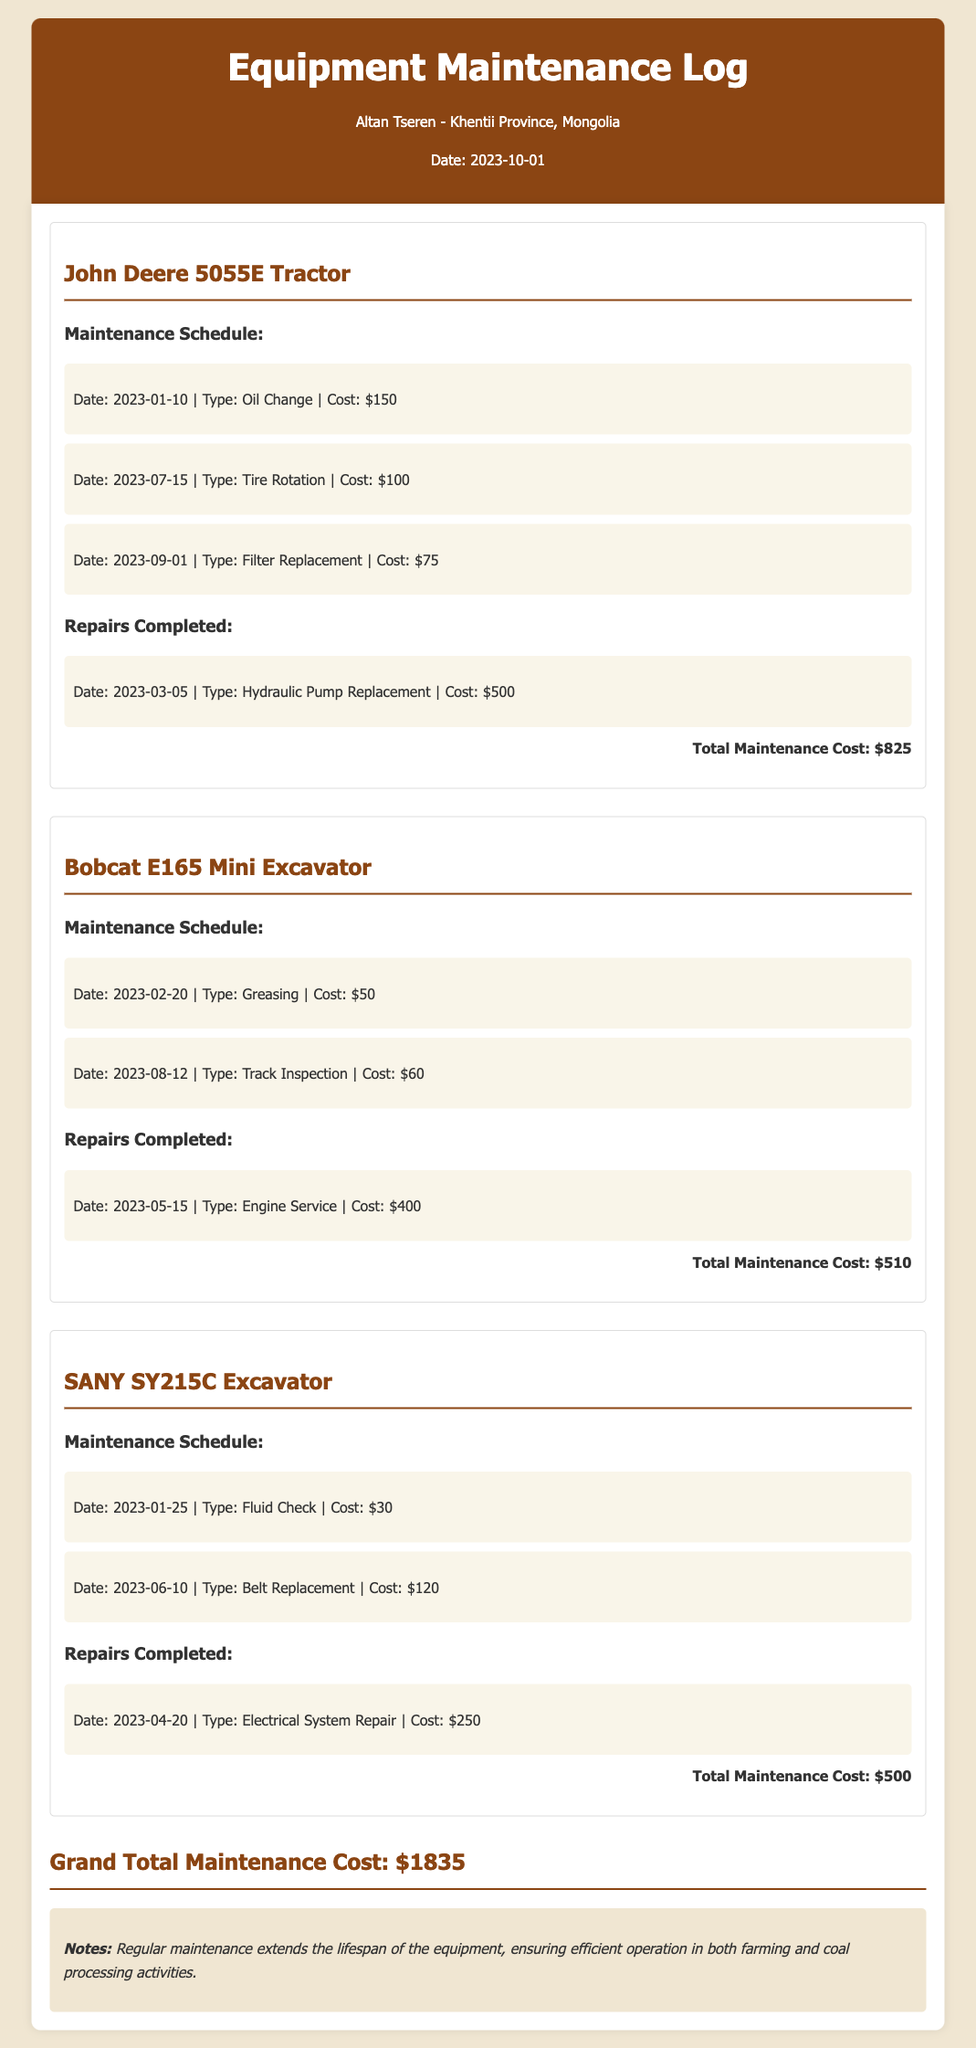What is the total maintenance cost for John Deere 5055E Tractor? The total maintenance cost for John Deere 5055E Tractor is listed at the end of its section, which sums up all the maintenance and repair costs for this equipment.
Answer: $825 When was the hydraulic pump replaced on the tractor? The repair date for the hydraulic pump replacement is stated in the repairs completed section under the tractor, detailing when this maintenance was performed.
Answer: 2023-03-05 How much did the engine service for the mini excavator cost? The cost for the engine service is provided in the repairs completed section for the mini excavator, specifying the amount spent on this maintenance.
Answer: $400 What is the total maintenance cost across all equipment? The grand total maintenance cost is explicitly stated at the end of the document, representing the sum of maintenance costs for all the listed equipment.
Answer: $1835 Which maintenance task was performed on the SANY SY215C Excavator in January? The maintenance schedule for the SANY SY215C Excavator lists a fluid check performed in January, citing the exact date and type of maintenance done.
Answer: Fluid Check What is the cost of the tire rotation for the tractor? The cost for the tire rotation is specified in the maintenance schedule for the tractor, detailing how much was spent on this particular task.
Answer: $100 Why is regular maintenance emphasized in the document? The notes section explains that regular maintenance extends the lifespan of the equipment, highlighting the importance of upkeep in the farming and coal processing activities.
Answer: To ensure efficient operation What type of equipment is mentioned alongside the Bobcat E165? The equipment listed alongside the Bobcat E165 in the document includes various types of machinery, requiring recognition of the specific types mentioned in the log for clarity.
Answer: Mini Excavator 